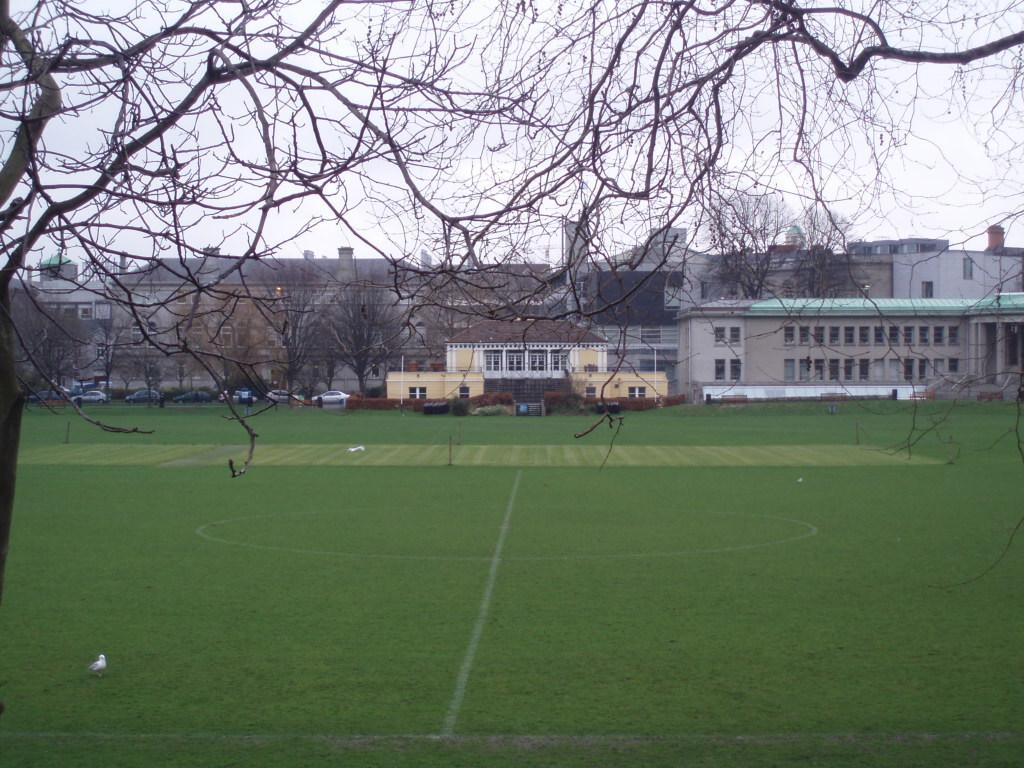What type of structures can be seen in the image? There are buildings in the image. What is located in front of the buildings? There is a ground in front of the buildings. What else can be seen in the image besides buildings? Vehicles and trees are present in the image. What is visible at the top of the image? The sky is visible at the top of the image. What type of orange is being used as a pet in the image? There is no orange or pet present in the image. 